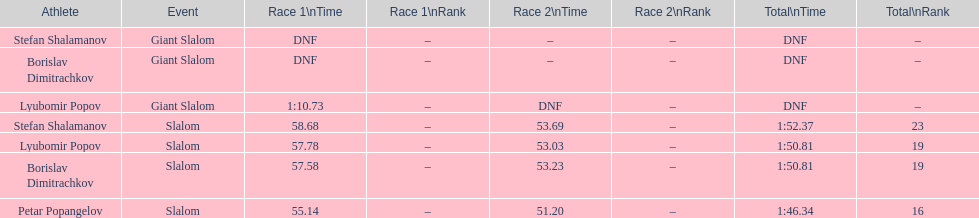Who came after borislav dimitrachkov and it's time for slalom Petar Popangelov. 